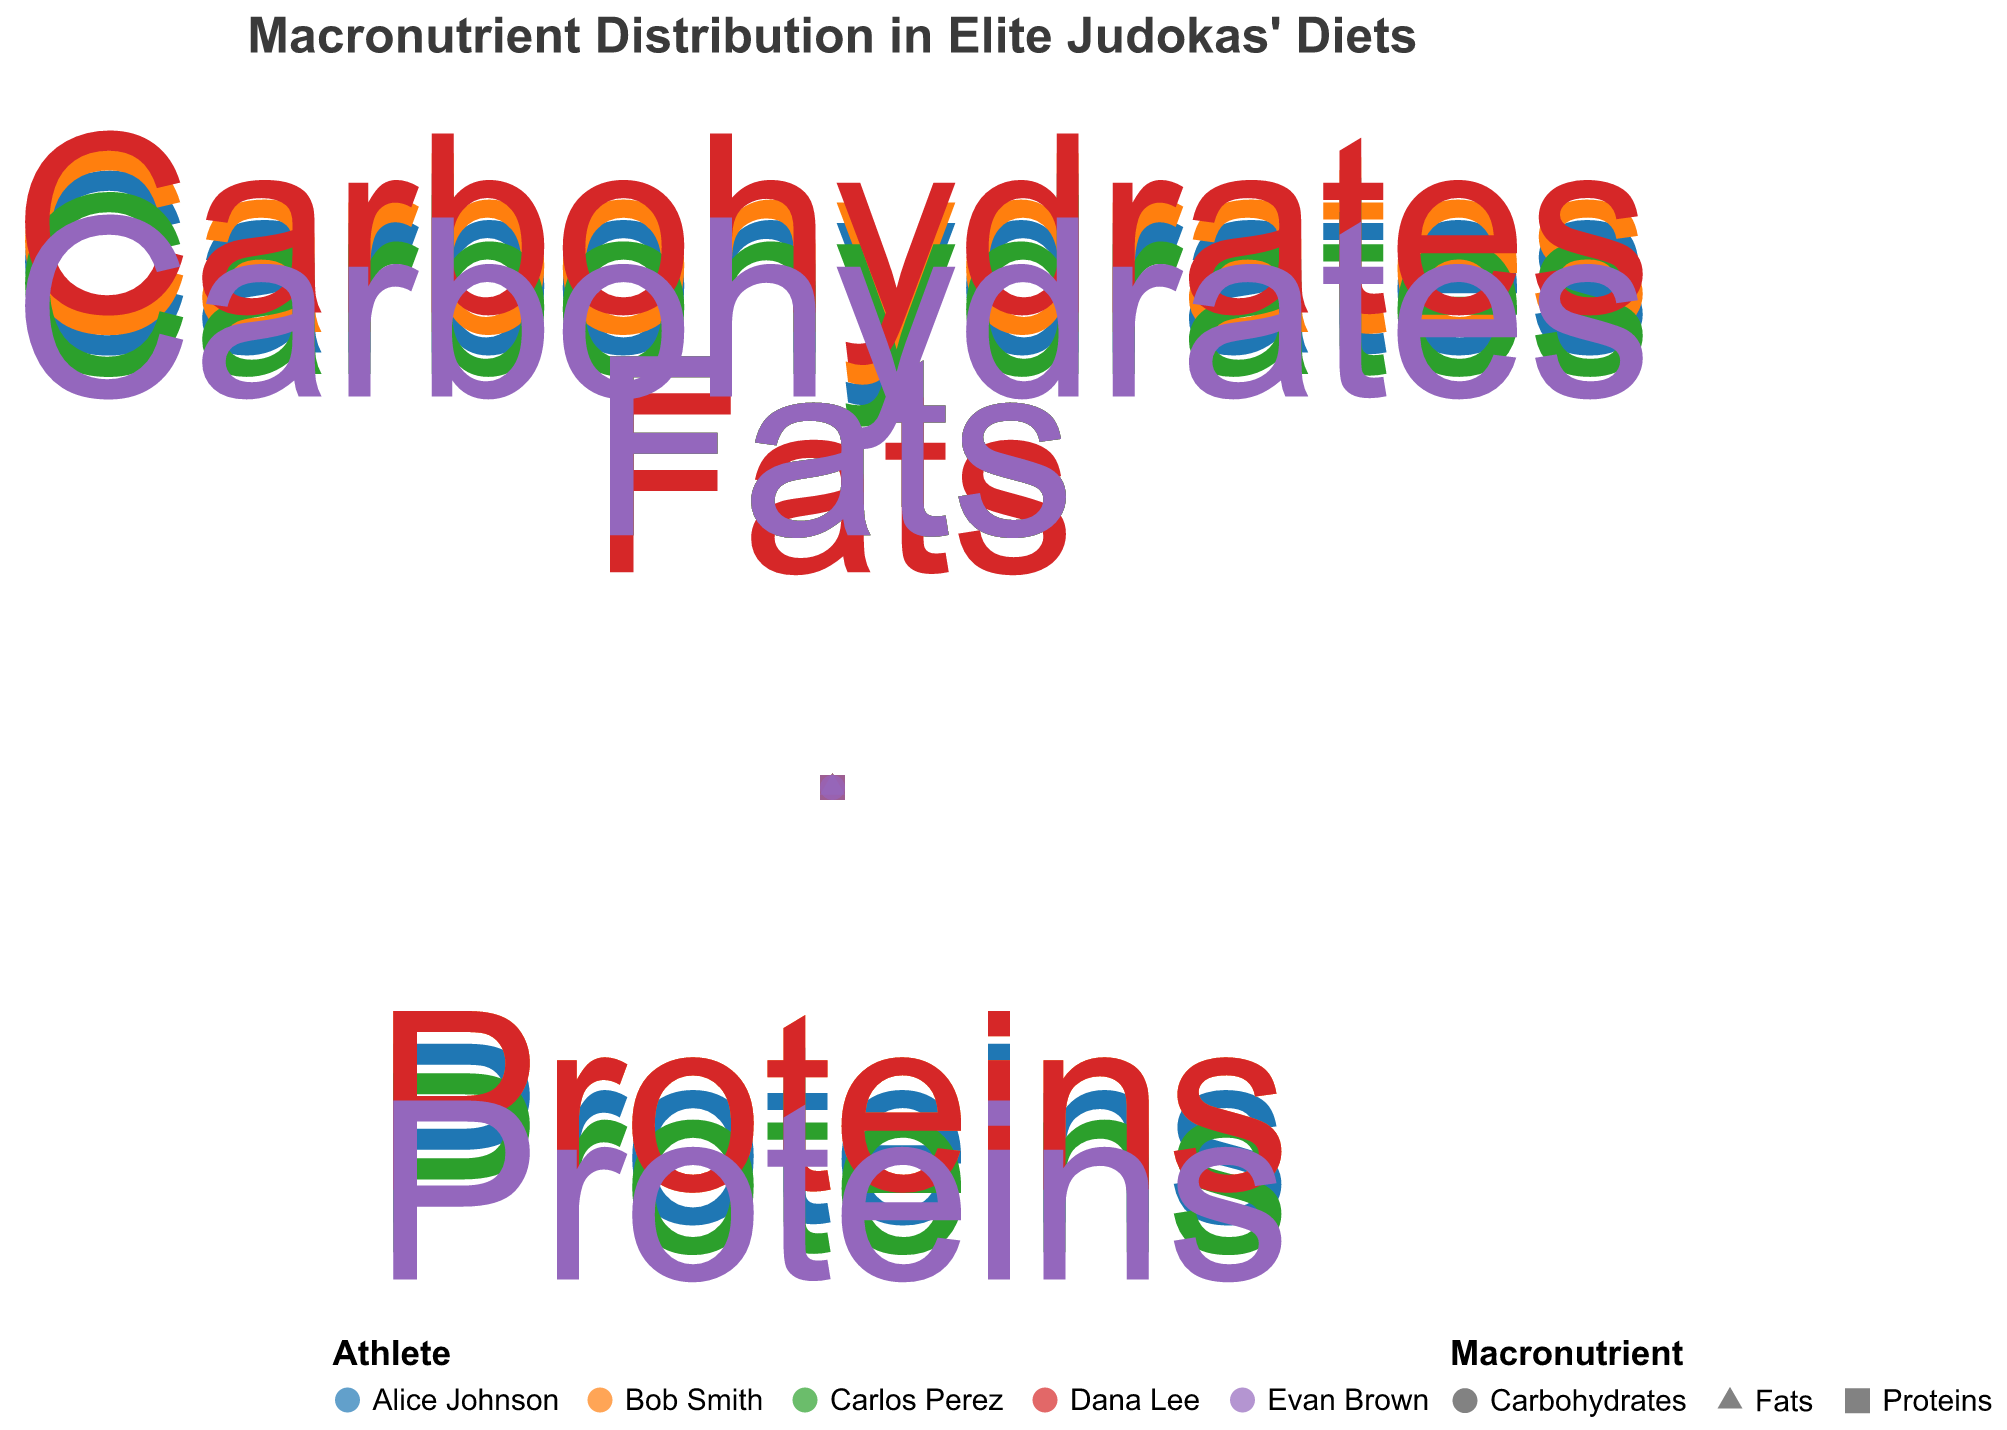What is the title of the figure? The title of the figure is prominently displayed at the top and reads "Macronutrient Distribution in Elite Judokas' Diets".
Answer: Macronutrient Distribution in Elite Judokas' Diets Which judoka has the highest amount of carbohydrates? Look for the data points labeled "Carbohydrates" and compare the amounts. Dana Lee has the highest value at 65.
Answer: Dana Lee What is the unique aspect of each macronutrient in the chart? Each macronutrient is represented by a different shape: Carbohydrates as circles, Proteins as triangles, and Fats as squares.
Answer: Different shapes What is the average amount of carbohydrates consumed by the judokas? Add the carbohydrate amounts for all athletes and divide by the number of athletes: (55 + 60 + 50 + 65 + 45) / 5 = 275 / 5.
Answer: 55 Whose diet contains the greatest proportion of proteins? Compare the protein values directly. Evan Brown has the highest at 35.
Answer: Evan Brown Which macronutrient is consistently at the same angle across all athletes? Check the angles for each macronutrient across all athletes. Carbohydrates are always at 0 degrees.
Answer: Carbohydrates How many athletes have the same amount of fats in their diet? Look at the amount values for fats across all athletes. Four of them (Alice Johnson, Bob Smith, Carlos Perez, Evan Brown) have 20.
Answer: 4 What is the total amount of proteins consumed by all judokas? Sum the protein amounts: 25 + 20 + 30 + 20 + 35.
Answer: 130 Who has the highest amount of fats and what is it? All values for fats should be checked first. The highest value is 20, but multiple athletes share this value. The names of those athletes are Alice Johnson, Bob Smith, Carlos Perez, and Evan Brown.
Answer: Alice Johnson, Bob Smith, Carlos Perez, Evan Brown, 20 Compare the sum of fats and proteins for Carlos Perez. Is it greater than the amount of carbohydrates he consumes? Calculate the sum for fats and proteins (30 + 20 = 50) and compare this sum to his carbohydrate amount (50). Since they are equal, it is not greater.
Answer: No 